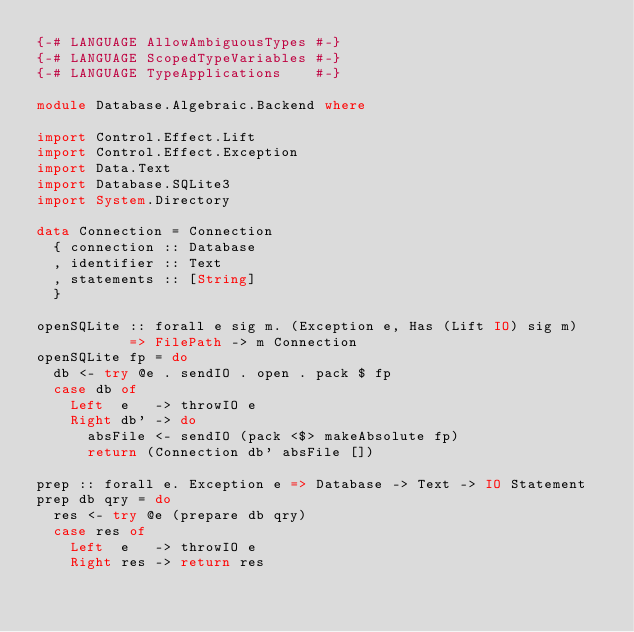Convert code to text. <code><loc_0><loc_0><loc_500><loc_500><_Haskell_>{-# LANGUAGE AllowAmbiguousTypes #-}
{-# LANGUAGE ScopedTypeVariables #-}
{-# LANGUAGE TypeApplications    #-}

module Database.Algebraic.Backend where

import Control.Effect.Lift
import Control.Effect.Exception
import Data.Text
import Database.SQLite3
import System.Directory

data Connection = Connection
  { connection :: Database
  , identifier :: Text
  , statements :: [String]
  }

openSQLite :: forall e sig m. (Exception e, Has (Lift IO) sig m)
           => FilePath -> m Connection
openSQLite fp = do
  db <- try @e . sendIO . open . pack $ fp
  case db of
    Left  e   -> throwIO e
    Right db' -> do
      absFile <- sendIO (pack <$> makeAbsolute fp)
      return (Connection db' absFile [])

prep :: forall e. Exception e => Database -> Text -> IO Statement
prep db qry = do
  res <- try @e (prepare db qry)
  case res of
    Left  e   -> throwIO e
    Right res -> return res
</code> 